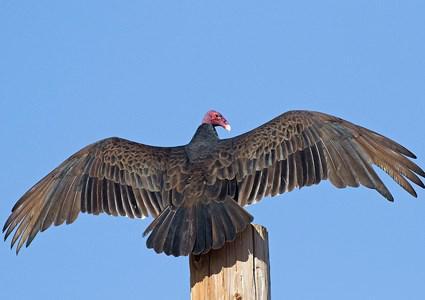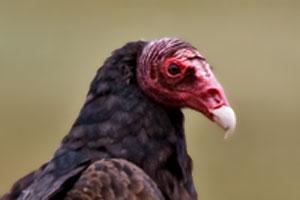The first image is the image on the left, the second image is the image on the right. Evaluate the accuracy of this statement regarding the images: "All of the birds are flying.". Is it true? Answer yes or no. No. The first image is the image on the left, the second image is the image on the right. Considering the images on both sides, is "The bird on the right image is facing right." valid? Answer yes or no. Yes. 